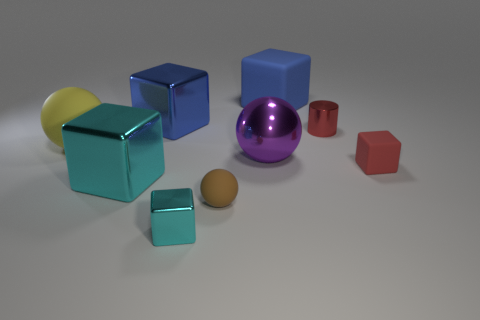Subtract 2 blocks. How many blocks are left? 3 Subtract all tiny metal cubes. How many cubes are left? 4 Subtract all red blocks. How many blocks are left? 4 Subtract all brown blocks. Subtract all gray balls. How many blocks are left? 5 Subtract all blocks. How many objects are left? 4 Add 9 yellow rubber objects. How many yellow rubber objects exist? 10 Subtract 0 purple cylinders. How many objects are left? 9 Subtract all cylinders. Subtract all small blocks. How many objects are left? 6 Add 4 big blue matte blocks. How many big blue matte blocks are left? 5 